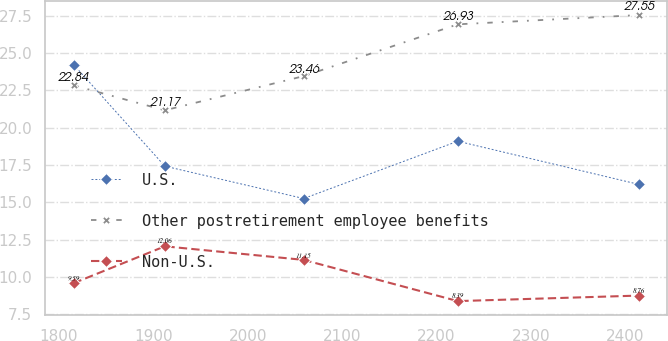Convert chart to OTSL. <chart><loc_0><loc_0><loc_500><loc_500><line_chart><ecel><fcel>U.S.<fcel>Other postretirement employee benefits<fcel>Non-U.S.<nl><fcel>1815.53<fcel>24.23<fcel>22.84<fcel>9.59<nl><fcel>1912.18<fcel>17.43<fcel>21.17<fcel>12.06<nl><fcel>2059.28<fcel>15.26<fcel>23.46<fcel>11.15<nl><fcel>2222.49<fcel>19.1<fcel>26.93<fcel>8.39<nl><fcel>2414.04<fcel>16.21<fcel>27.55<fcel>8.76<nl></chart> 